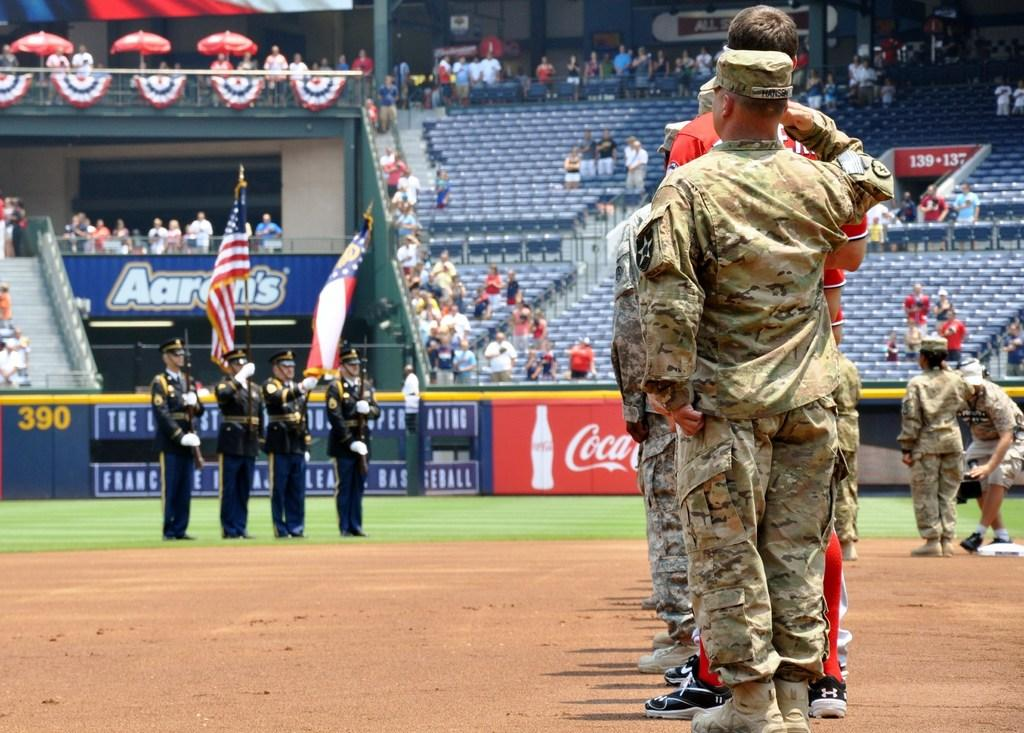Provide a one-sentence caption for the provided image. Soldiers and military men are on a baseball fielld an there is a coca cola sign displayed. 